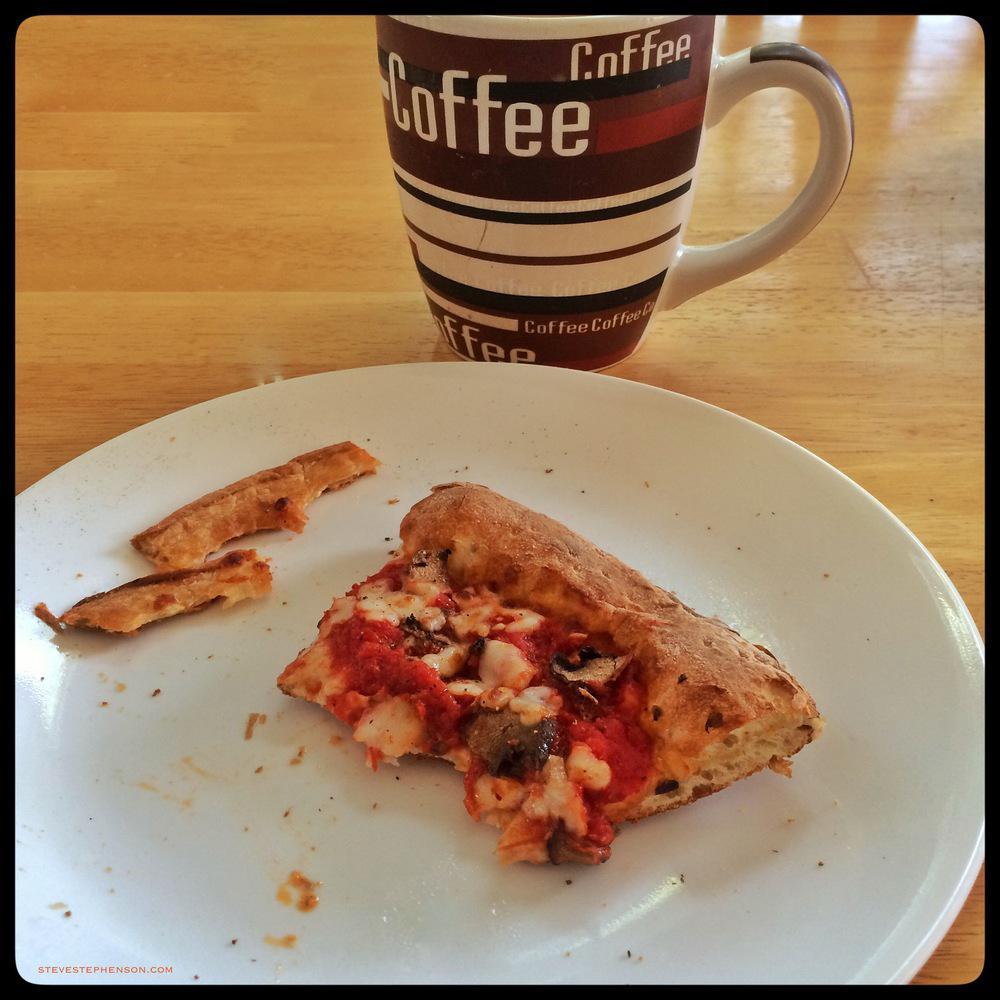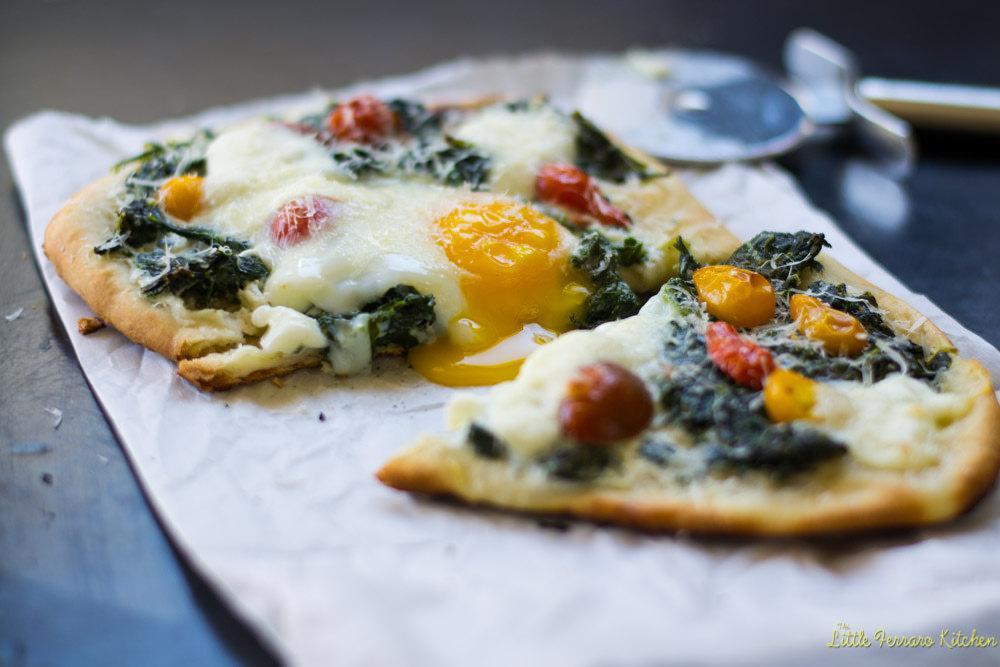The first image is the image on the left, the second image is the image on the right. Evaluate the accuracy of this statement regarding the images: "The right image shows only breakfast pizza.". Is it true? Answer yes or no. Yes. 